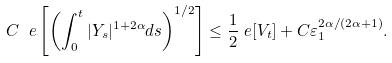<formula> <loc_0><loc_0><loc_500><loc_500>C \ e \left [ \left ( \int _ { 0 } ^ { t } | Y _ { s } | ^ { 1 + 2 \alpha } d s \right ) ^ { 1 / 2 } \right ] & \leq \frac { 1 } { 2 } \ e [ V _ { t } ] + C \varepsilon _ { 1 } ^ { 2 \alpha / ( 2 \alpha + 1 ) } .</formula> 